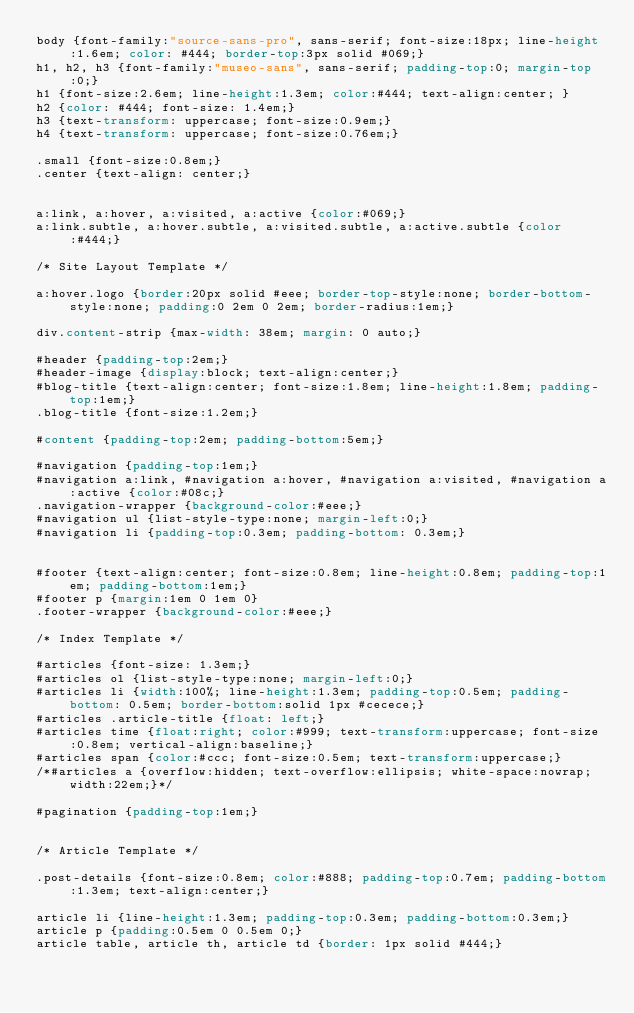Convert code to text. <code><loc_0><loc_0><loc_500><loc_500><_CSS_>body {font-family:"source-sans-pro", sans-serif; font-size:18px; line-height:1.6em; color: #444; border-top:3px solid #069;}
h1, h2, h3 {font-family:"museo-sans", sans-serif; padding-top:0; margin-top:0;}
h1 {font-size:2.6em; line-height:1.3em; color:#444; text-align:center; }
h2 {color: #444; font-size: 1.4em;}
h3 {text-transform: uppercase; font-size:0.9em;}	
h4 {text-transform: uppercase; font-size:0.76em;}

.small {font-size:0.8em;}
.center {text-align: center;}


a:link, a:hover, a:visited, a:active {color:#069;}
a:link.subtle, a:hover.subtle, a:visited.subtle, a:active.subtle {color:#444;}

/* Site Layout Template */

a:hover.logo {border:20px solid #eee; border-top-style:none; border-bottom-style:none; padding:0 2em 0 2em; border-radius:1em;}

div.content-strip {max-width: 38em; margin: 0 auto;}

#header {padding-top:2em;}
#header-image {display:block; text-align:center;}
#blog-title {text-align:center; font-size:1.8em; line-height:1.8em; padding-top:1em;}
.blog-title {font-size:1.2em;}

#content {padding-top:2em; padding-bottom:5em;}

#navigation {padding-top:1em;}
#navigation a:link, #navigation a:hover, #navigation a:visited, #navigation a:active {color:#08c;}
.navigation-wrapper {background-color:#eee;}
#navigation ul {list-style-type:none; margin-left:0;}
#navigation li {padding-top:0.3em; padding-bottom: 0.3em;}


#footer {text-align:center; font-size:0.8em; line-height:0.8em; padding-top:1em; padding-bottom:1em;}
#footer p {margin:1em 0 1em 0}
.footer-wrapper {background-color:#eee;}

/* Index Template */

#articles {font-size: 1.3em;}
#articles ol {list-style-type:none; margin-left:0;}
#articles li {width:100%; line-height:1.3em; padding-top:0.5em; padding-bottom: 0.5em; border-bottom:solid 1px #cecece;}
#articles .article-title {float: left;}
#articles time {float:right; color:#999; text-transform:uppercase; font-size:0.8em; vertical-align:baseline;}
#articles span {color:#ccc; font-size:0.5em; text-transform:uppercase;}
/*#articles a {overflow:hidden; text-overflow:ellipsis; white-space:nowrap; width:22em;}*/

#pagination {padding-top:1em;}


/* Article Template */

.post-details {font-size:0.8em; color:#888; padding-top:0.7em; padding-bottom:1.3em; text-align:center;}

article li {line-height:1.3em; padding-top:0.3em; padding-bottom:0.3em;}
article p {padding:0.5em 0 0.5em 0;}
article table, article th, article td {border: 1px solid #444;}
</code> 